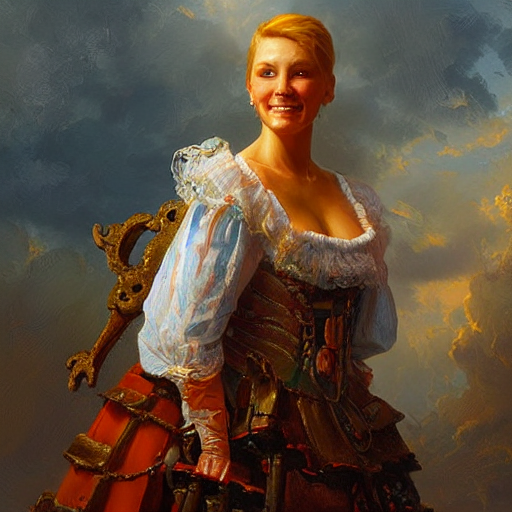What historical era does the style of clothing in the image suggest? The style of clothing in the image suggests a historical era resembling the European Renaissance, characterized by ornate details, rich fabrics, and a structured silhouette. 